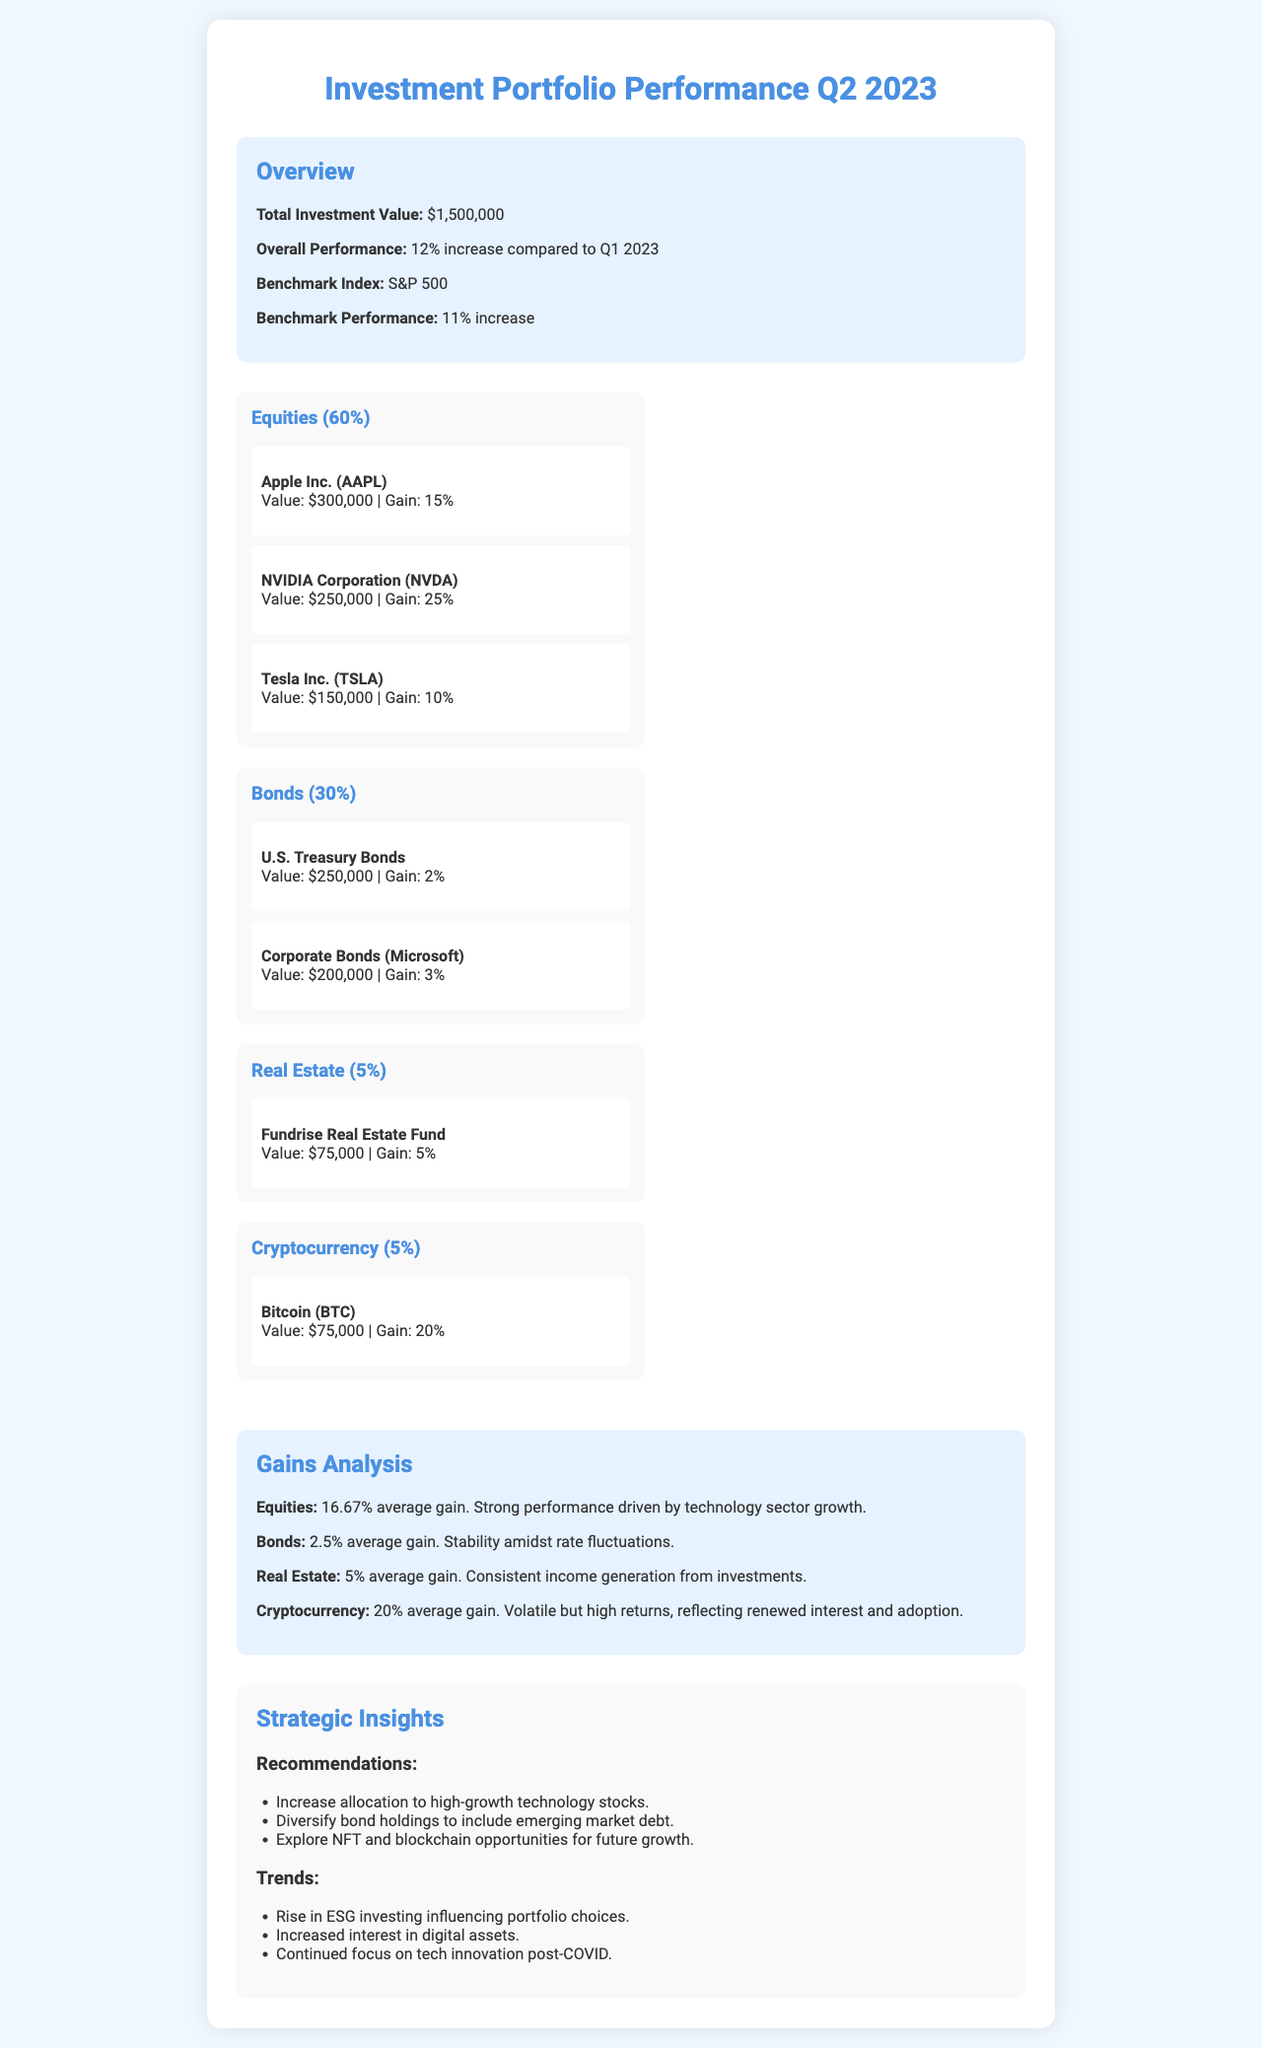What is the total investment value? The total investment value is stated in the overview section of the document, which is $1,500,000.
Answer: $1,500,000 What was the overall performance compared to Q1 2023? The overall performance is indicated as a 12% increase compared to Q1 2023 in the overview section.
Answer: 12% increase What is the allocation percentage for Equities? The percentage for Equities is specified in the allocation section, which is 60%.
Answer: 60% Which asset had the highest gain? The highest gain is attributed to NVIDIA Corporation (NVDA) with a gain of 25%, as shown in the allocation section.
Answer: 25% What is the average gain for Equities? The average gain for Equities is provided in the gains analysis section, which is 16.67%.
Answer: 16.67% What type of bonds does the portfolio include? The portfolio includes U.S. Treasury Bonds and Corporate Bonds (Microsoft), indicated in the allocation section.
Answer: U.S. Treasury Bonds and Corporate Bonds (Microsoft) What is one of the recommendations made in the strategic insights? A recommendation is to increase allocation to high-growth technology stocks, stated in the strategic insights section.
Answer: Increase allocation to high-growth technology stocks What impact is noted from ESG investing? The document highlights a rise in ESG investing influencing portfolio choices, mentioned in the trends section.
Answer: Influencing portfolio choices What is the performance of cryptocurrency in this quarter? The performance of cryptocurrency is indicated as a 20% average gain in the gains analysis section.
Answer: 20% average gain 